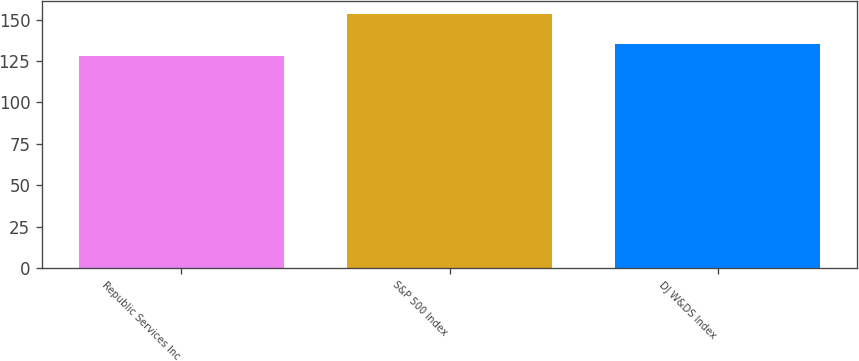<chart> <loc_0><loc_0><loc_500><loc_500><bar_chart><fcel>Republic Services Inc<fcel>S&P 500 Index<fcel>DJ W&DS Index<nl><fcel>128.3<fcel>153.57<fcel>135.56<nl></chart> 